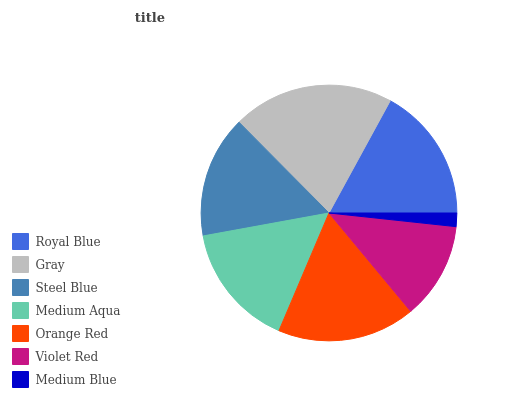Is Medium Blue the minimum?
Answer yes or no. Yes. Is Gray the maximum?
Answer yes or no. Yes. Is Steel Blue the minimum?
Answer yes or no. No. Is Steel Blue the maximum?
Answer yes or no. No. Is Gray greater than Steel Blue?
Answer yes or no. Yes. Is Steel Blue less than Gray?
Answer yes or no. Yes. Is Steel Blue greater than Gray?
Answer yes or no. No. Is Gray less than Steel Blue?
Answer yes or no. No. Is Medium Aqua the high median?
Answer yes or no. Yes. Is Medium Aqua the low median?
Answer yes or no. Yes. Is Steel Blue the high median?
Answer yes or no. No. Is Violet Red the low median?
Answer yes or no. No. 